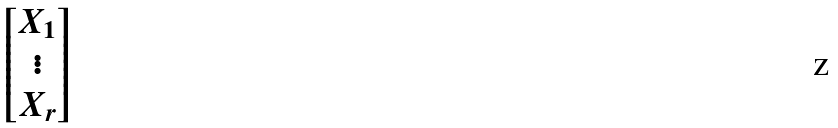Convert formula to latex. <formula><loc_0><loc_0><loc_500><loc_500>\begin{bmatrix} X _ { 1 } \\ \vdots \\ X _ { r } \end{bmatrix}</formula> 